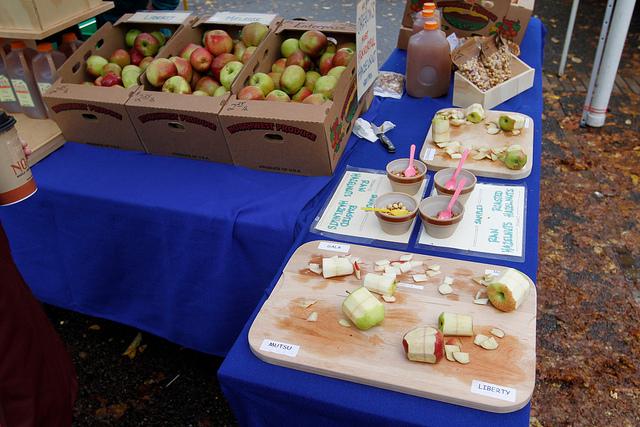Who is in the photo?
Concise answer only. Nobody. How many pink spoons are there?
Write a very short answer. 3. What color is the tablecloth?
Short answer required. Blue. 